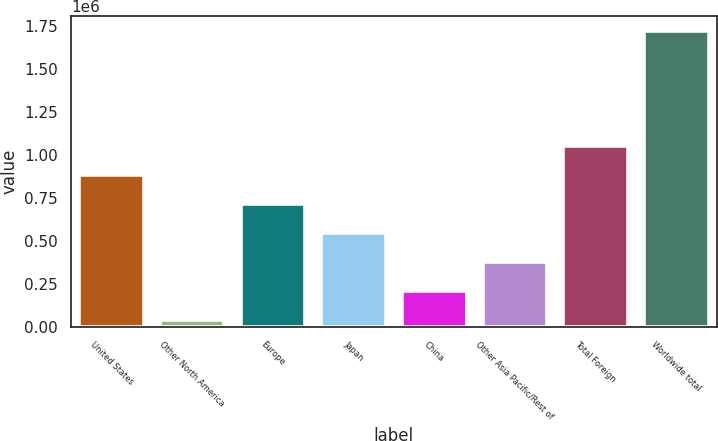<chart> <loc_0><loc_0><loc_500><loc_500><bar_chart><fcel>United States<fcel>Other North America<fcel>Europe<fcel>Japan<fcel>China<fcel>Other Asia Pacific/Rest of<fcel>Total Foreign<fcel>Worldwide total<nl><fcel>882162<fcel>38074<fcel>713344<fcel>544527<fcel>206892<fcel>375709<fcel>1.05098e+06<fcel>1.72625e+06<nl></chart> 